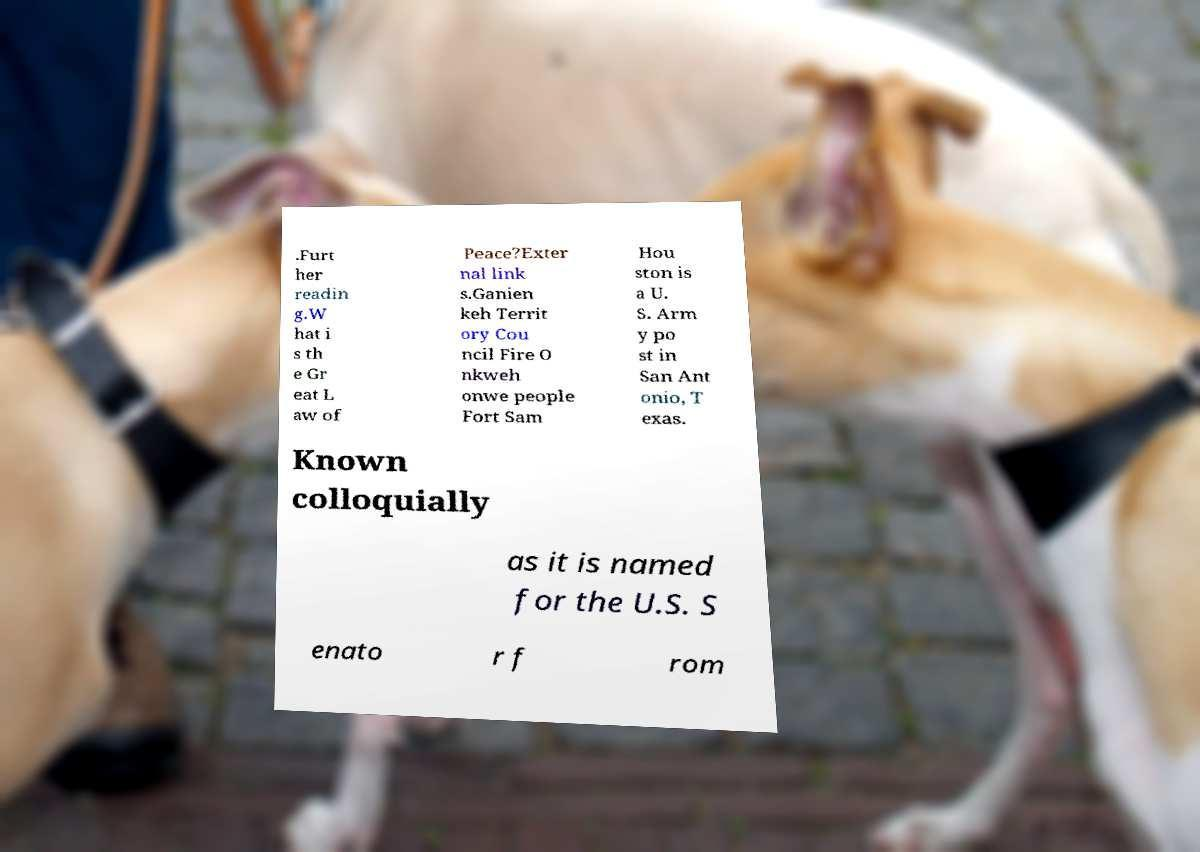For documentation purposes, I need the text within this image transcribed. Could you provide that? .Furt her readin g.W hat i s th e Gr eat L aw of Peace?Exter nal link s.Ganien keh Territ ory Cou ncil Fire O nkweh onwe people Fort Sam Hou ston is a U. S. Arm y po st in San Ant onio, T exas. Known colloquially as it is named for the U.S. S enato r f rom 